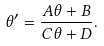Convert formula to latex. <formula><loc_0><loc_0><loc_500><loc_500>\theta ^ { \prime } = \frac { A \theta + B } { C \theta + D } .</formula> 